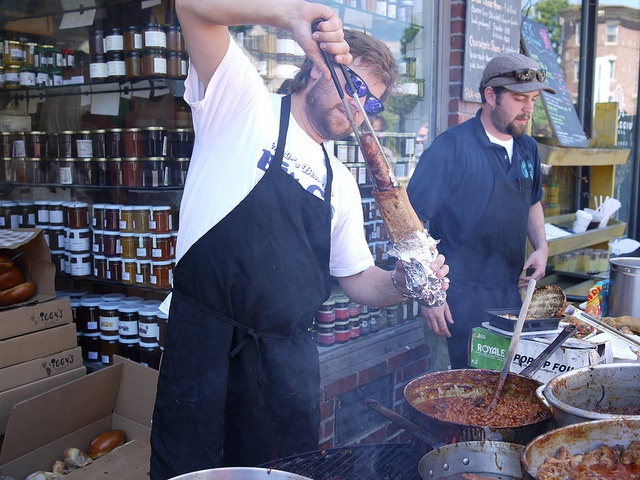Describe the objects in this image and their specific colors. I can see people in black, lavender, navy, and darkgray tones, bottle in black, gray, and lavender tones, people in black, darkblue, navy, and blue tones, bowl in black, gray, and maroon tones, and bowl in black, gray, darkgray, and lavender tones in this image. 